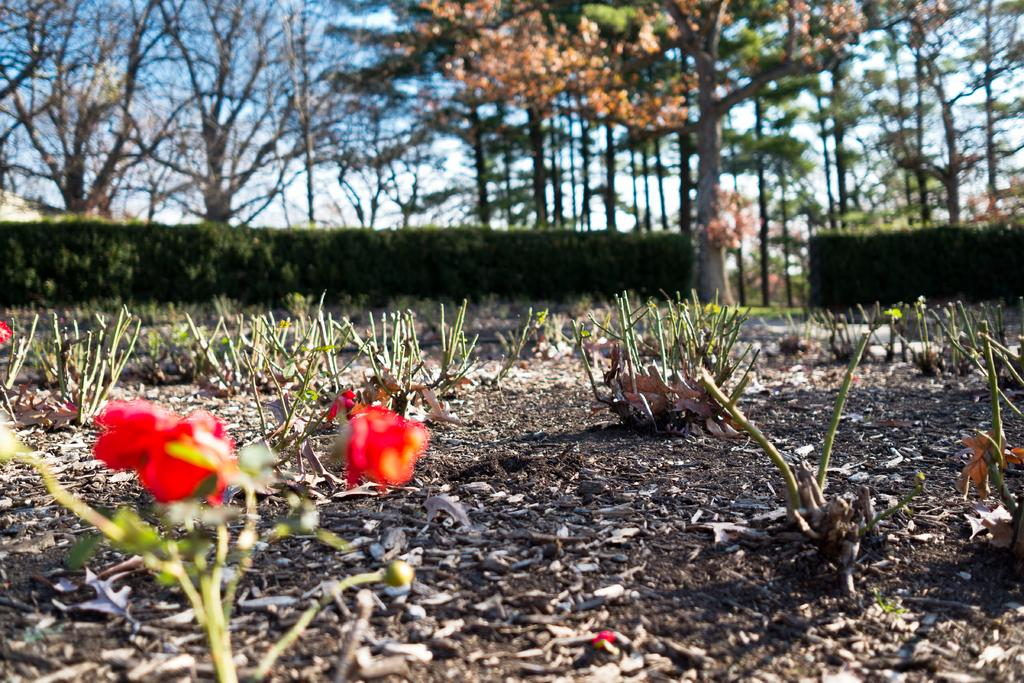What type of plant life can be seen on the ground in the image? There are stems of plants on the ground in the image. What is located in the foreground of the image? There are flowers in the foreground of the image. What type of plant life can be seen in the background of the image? There are hedges and trees in the background of the image. What is visible at the top of the image? The sky is visible at the top of the image. What type of toys can be seen in the image? There are no toys present in the image. What pet can be seen interacting with the flowers in the foreground? There is no pet present in the image; it only features plants and flowers. 